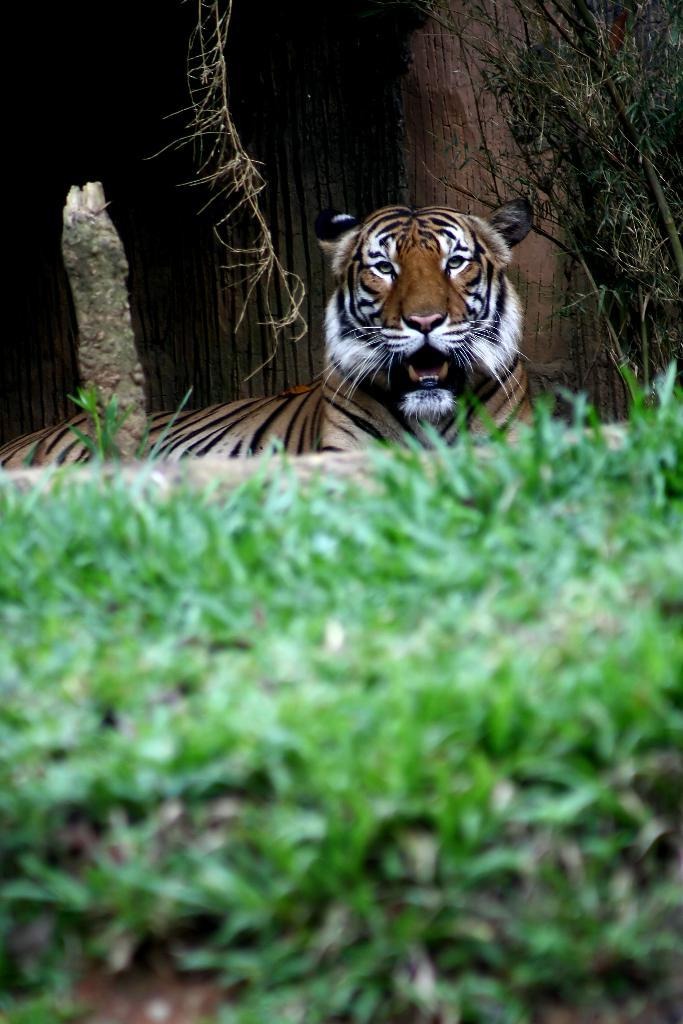What animal in the image? There is a tiger sitting in the image. What can be seen in the background of the image? There is a tree in the background of the image. What type of vegetation is in the foreground of the image? There is grass in the foreground of the image. What type of screw can be seen holding the tiger's tail in the image? There is no screw present in the image, and the tiger's tail is not held by any object. 